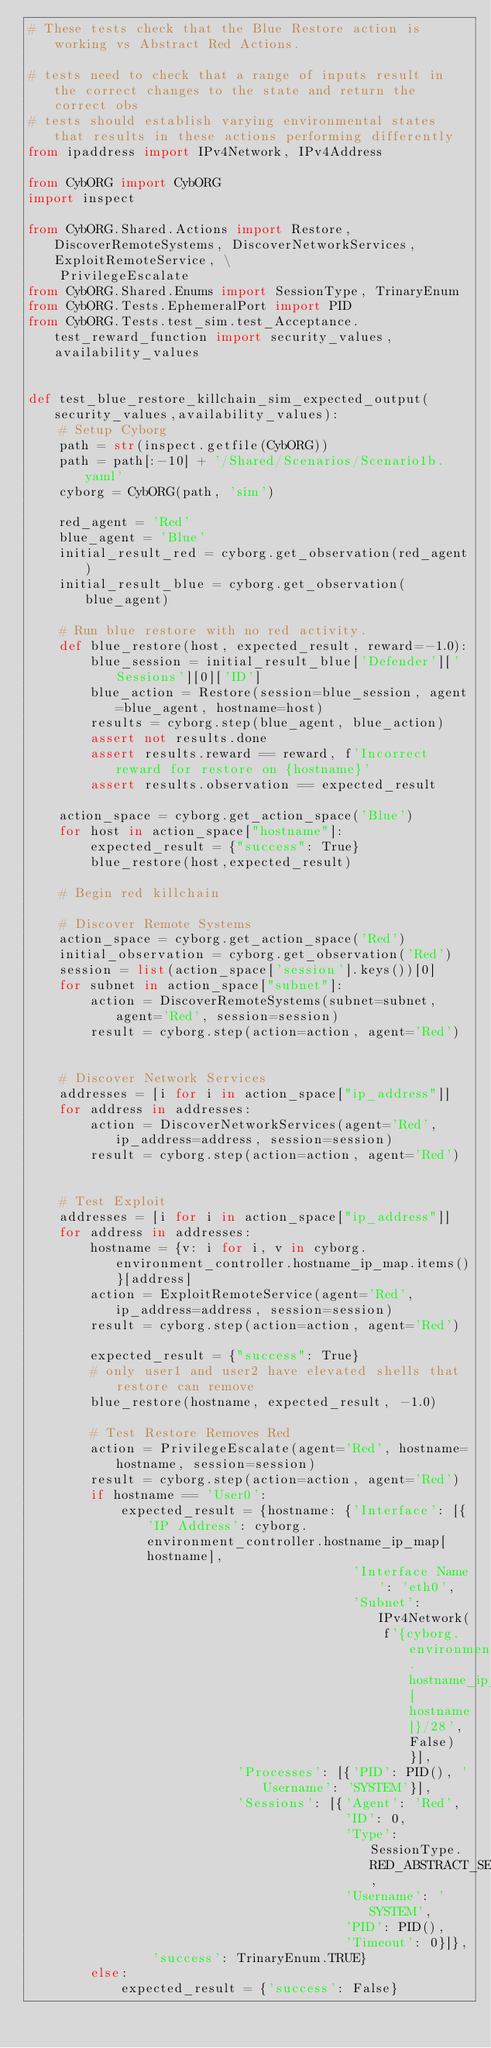Convert code to text. <code><loc_0><loc_0><loc_500><loc_500><_Python_># These tests check that the Blue Restore action is working vs Abstract Red Actions.    
    
# tests need to check that a range of inputs result in the correct changes to the state and return the correct obs
# tests should establish varying environmental states that results in these actions performing differently
from ipaddress import IPv4Network, IPv4Address    
    
from CybORG import CybORG    
import inspect

from CybORG.Shared.Actions import Restore, DiscoverRemoteSystems, DiscoverNetworkServices, ExploitRemoteService, \
    PrivilegeEscalate
from CybORG.Shared.Enums import SessionType, TrinaryEnum
from CybORG.Tests.EphemeralPort import PID
from CybORG.Tests.test_sim.test_Acceptance.test_reward_function import security_values, availability_values


def test_blue_restore_killchain_sim_expected_output(security_values,availability_values):
    # Setup Cyborg
    path = str(inspect.getfile(CybORG))
    path = path[:-10] + '/Shared/Scenarios/Scenario1b.yaml'
    cyborg = CybORG(path, 'sim')

    red_agent = 'Red'
    blue_agent = 'Blue'
    initial_result_red = cyborg.get_observation(red_agent)
    initial_result_blue = cyborg.get_observation(blue_agent)

    # Run blue restore with no red activity.
    def blue_restore(host, expected_result, reward=-1.0):
        blue_session = initial_result_blue['Defender']['Sessions'][0]['ID']
        blue_action = Restore(session=blue_session, agent=blue_agent, hostname=host)
        results = cyborg.step(blue_agent, blue_action)
        assert not results.done
        assert results.reward == reward, f'Incorrect reward for restore on {hostname}'
        assert results.observation == expected_result

    action_space = cyborg.get_action_space('Blue')
    for host in action_space["hostname"]:
        expected_result = {"success": True}
        blue_restore(host,expected_result)

    # Begin red killchain

    # Discover Remote Systems
    action_space = cyborg.get_action_space('Red')
    initial_observation = cyborg.get_observation('Red')
    session = list(action_space['session'].keys())[0]
    for subnet in action_space["subnet"]:
        action = DiscoverRemoteSystems(subnet=subnet, agent='Red', session=session)
        result = cyborg.step(action=action, agent='Red')


    # Discover Network Services
    addresses = [i for i in action_space["ip_address"]]
    for address in addresses:
        action = DiscoverNetworkServices(agent='Red', ip_address=address, session=session)
        result = cyborg.step(action=action, agent='Red')


    # Test Exploit
    addresses = [i for i in action_space["ip_address"]]
    for address in addresses:
        hostname = {v: i for i, v in cyborg.environment_controller.hostname_ip_map.items()}[address]
        action = ExploitRemoteService(agent='Red', ip_address=address, session=session)
        result = cyborg.step(action=action, agent='Red')

        expected_result = {"success": True}
        # only user1 and user2 have elevated shells that restore can remove
        blue_restore(hostname, expected_result, -1.0)

        # Test Restore Removes Red
        action = PrivilegeEscalate(agent='Red', hostname=hostname, session=session)
        result = cyborg.step(action=action, agent='Red')
        if hostname == 'User0':
            expected_result = {hostname: {'Interface': [{'IP Address': cyborg.environment_controller.hostname_ip_map[hostname],
                                          'Interface Name': 'eth0',
                                          'Subnet': IPv4Network(
                                              f'{cyborg.environment_controller.hostname_ip_map[hostname]}/28', False)}],
                           'Processes': [{'PID': PID(), 'Username': 'SYSTEM'}],
                           'Sessions': [{'Agent': 'Red',
                                         'ID': 0,
                                         'Type': SessionType.RED_ABSTRACT_SESSION,
                                         'Username': 'SYSTEM',
                                         'PID': PID(),
                                         'Timeout': 0}]},
                'success': TrinaryEnum.TRUE}
        else:
            expected_result = {'success': False}</code> 